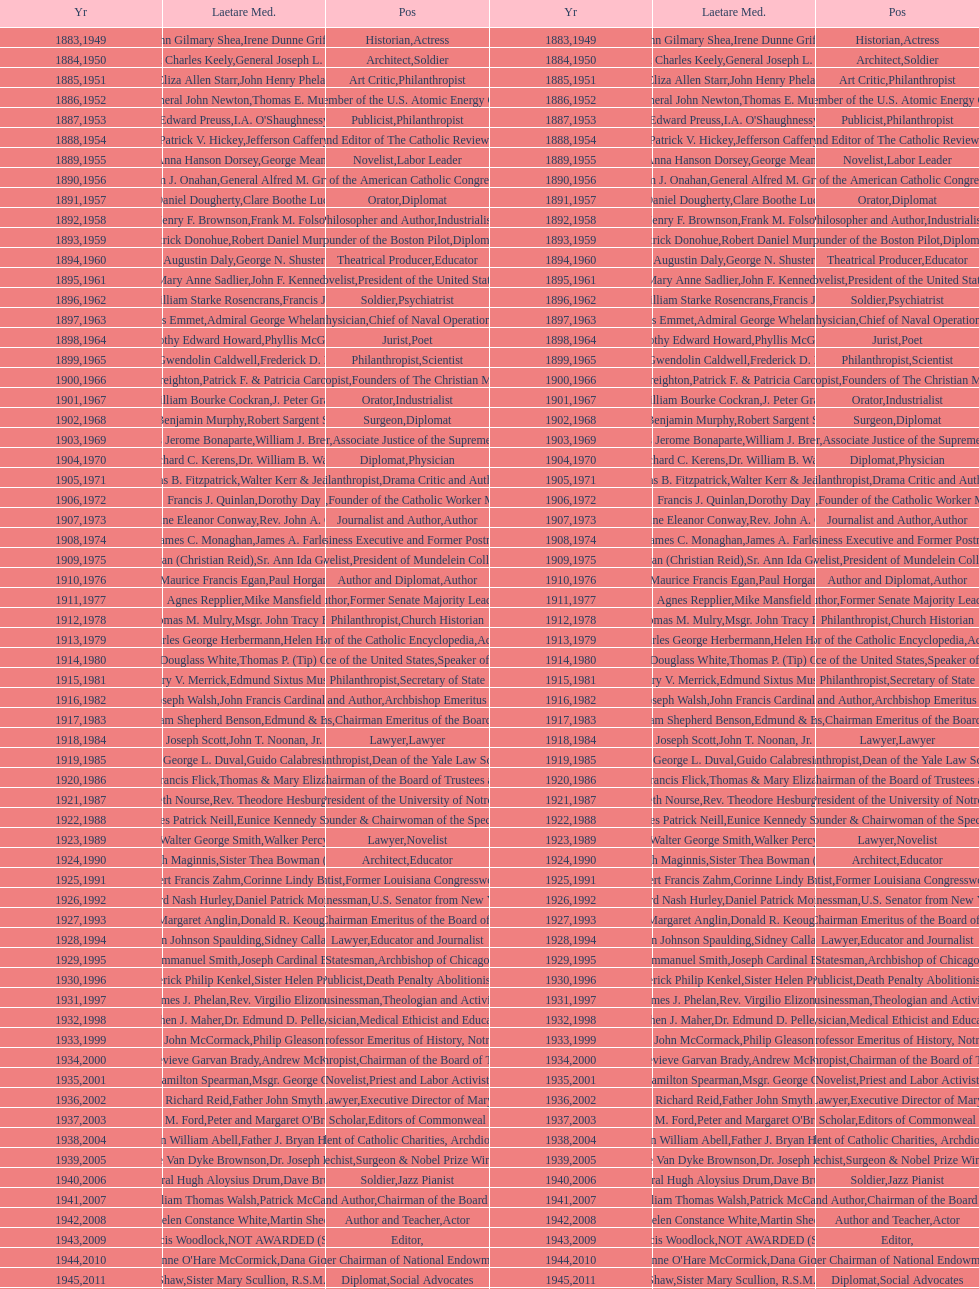Who won the medal after thomas e. murray in 1952? I.A. O'Shaughnessy. 